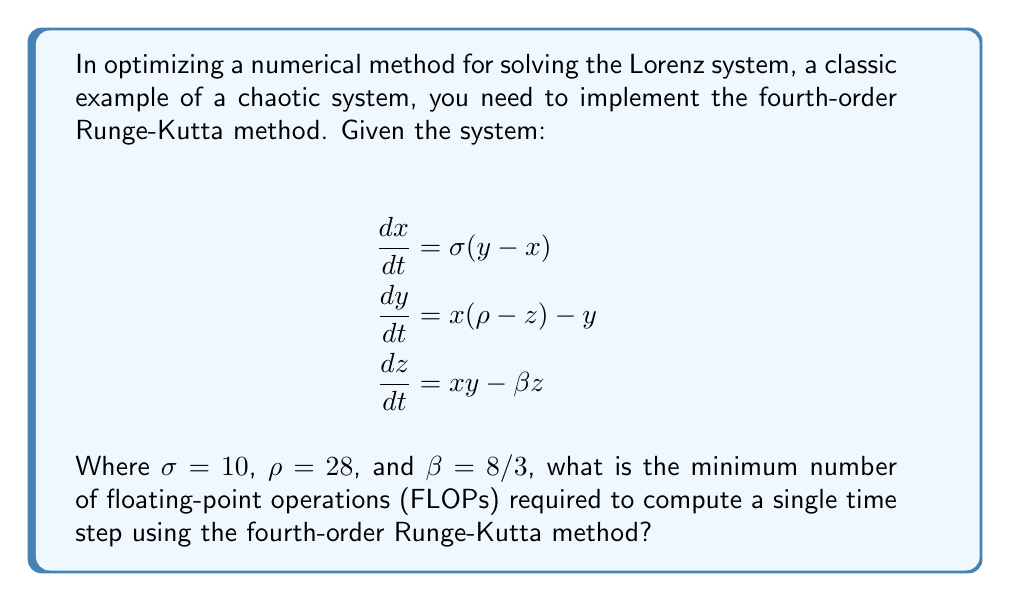Help me with this question. Let's break this down step-by-step:

1) The fourth-order Runge-Kutta method for a system of ODEs is given by:

   $$k_1 = hf(t_n, y_n)$$
   $$k_2 = hf(t_n + \frac{h}{2}, y_n + \frac{k_1}{2})$$
   $$k_3 = hf(t_n + \frac{h}{2}, y_n + \frac{k_2}{2})$$
   $$k_4 = hf(t_n + h, y_n + k_3)$$
   $$y_{n+1} = y_n + \frac{1}{6}(k_1 + 2k_2 + 2k_3 + k_4)$$

2) In our case, $f$ is a vector-valued function with three components (dx/dt, dy/dt, dz/dt).

3) Let's count the FLOPs for each evaluation of $f$:
   - dx/dt: 2 FLOPs (1 subtraction, 1 multiplication)
   - dy/dt: 4 FLOPs (1 subtraction, 2 multiplications, 1 addition)
   - dz/dt: 3 FLOPs (2 multiplications, 1 subtraction)
   Total: 9 FLOPs per evaluation of $f$

4) We need to evaluate $f$ four times for $k_1$, $k_2$, $k_3$, and $k_4$: 4 * 9 = 36 FLOPs

5) For each $k_i$ (i = 2, 3, 4), we need to add $y_n + \frac{k_{i-1}}{2}$. This is 3 additions and 3 divisions for each component, so 6 * 3 = 18 FLOPs for each $k_i$. Total: 3 * 18 = 54 FLOPs

6) For the final step, we need to compute $\frac{1}{6}(k_1 + 2k_2 + 2k_3 + k_4)$ for each component:
   - 4 additions and 3 multiplications per component: 7 * 3 = 21 FLOPs
   - 3 divisions (by 6) and 3 additions (to $y_n$): 6 FLOPs
   Total: 27 FLOPs

7) Sum up all FLOPs: 36 + 54 + 27 = 117 FLOPs

Therefore, the minimum number of FLOPs required for a single time step is 117.
Answer: 117 FLOPs 